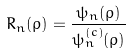<formula> <loc_0><loc_0><loc_500><loc_500>R _ { n } ( \rho ) = \frac { \psi _ { n } ( \rho ) } { \psi _ { n } ^ { ( c ) } ( \rho ) }</formula> 